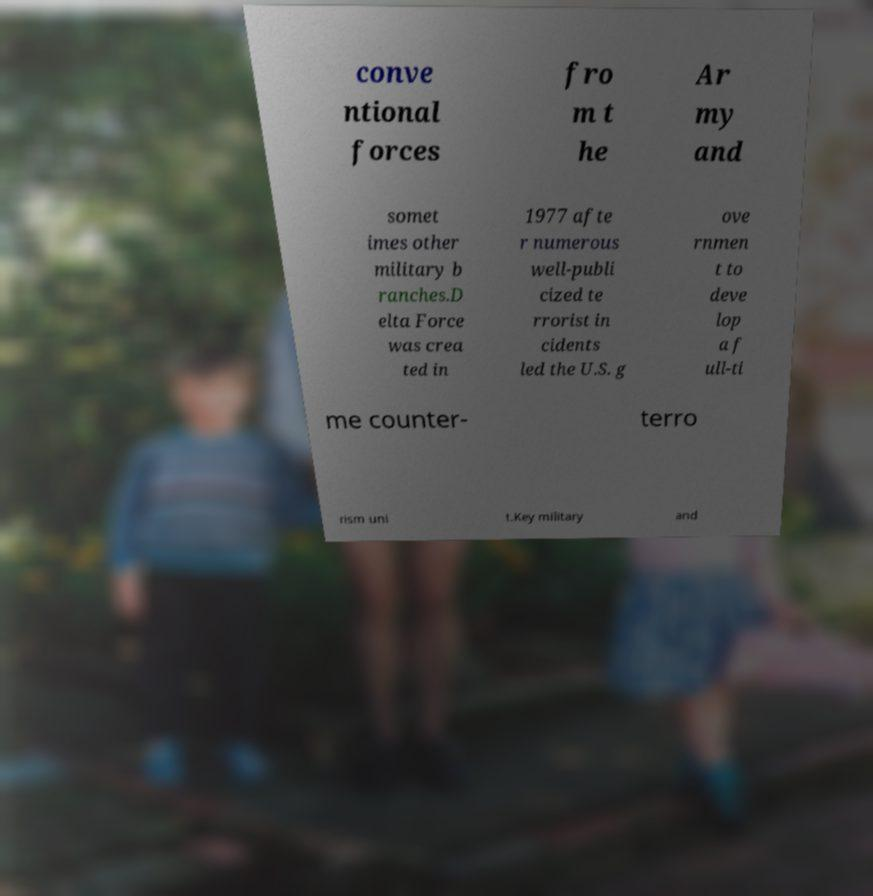Could you extract and type out the text from this image? conve ntional forces fro m t he Ar my and somet imes other military b ranches.D elta Force was crea ted in 1977 afte r numerous well-publi cized te rrorist in cidents led the U.S. g ove rnmen t to deve lop a f ull-ti me counter- terro rism uni t.Key military and 